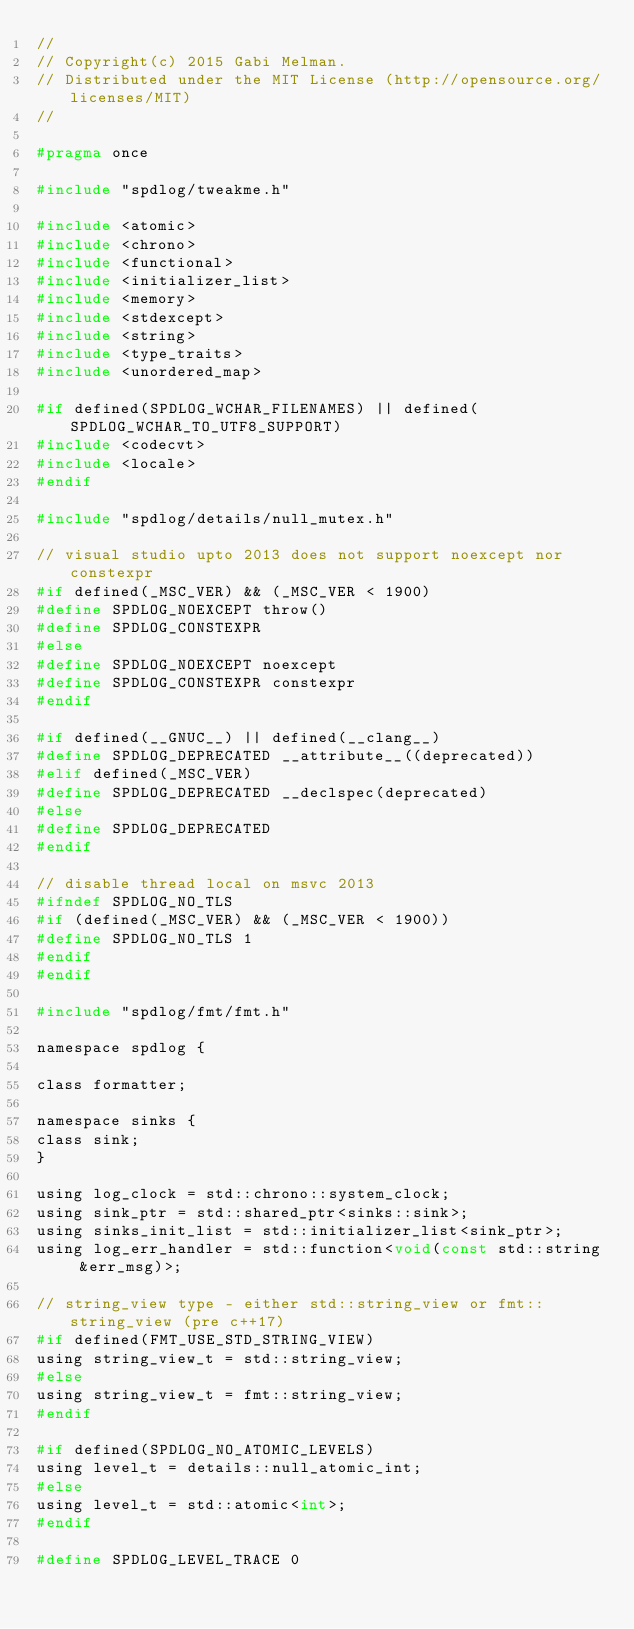Convert code to text. <code><loc_0><loc_0><loc_500><loc_500><_C_>//
// Copyright(c) 2015 Gabi Melman.
// Distributed under the MIT License (http://opensource.org/licenses/MIT)
//

#pragma once

#include "spdlog/tweakme.h"

#include <atomic>
#include <chrono>
#include <functional>
#include <initializer_list>
#include <memory>
#include <stdexcept>
#include <string>
#include <type_traits>
#include <unordered_map>

#if defined(SPDLOG_WCHAR_FILENAMES) || defined(SPDLOG_WCHAR_TO_UTF8_SUPPORT)
#include <codecvt>
#include <locale>
#endif

#include "spdlog/details/null_mutex.h"

// visual studio upto 2013 does not support noexcept nor constexpr
#if defined(_MSC_VER) && (_MSC_VER < 1900)
#define SPDLOG_NOEXCEPT throw()
#define SPDLOG_CONSTEXPR
#else
#define SPDLOG_NOEXCEPT noexcept
#define SPDLOG_CONSTEXPR constexpr
#endif

#if defined(__GNUC__) || defined(__clang__)
#define SPDLOG_DEPRECATED __attribute__((deprecated))
#elif defined(_MSC_VER)
#define SPDLOG_DEPRECATED __declspec(deprecated)
#else
#define SPDLOG_DEPRECATED
#endif

// disable thread local on msvc 2013
#ifndef SPDLOG_NO_TLS
#if (defined(_MSC_VER) && (_MSC_VER < 1900))
#define SPDLOG_NO_TLS 1
#endif
#endif

#include "spdlog/fmt/fmt.h"

namespace spdlog {

class formatter;

namespace sinks {
class sink;
}

using log_clock = std::chrono::system_clock;
using sink_ptr = std::shared_ptr<sinks::sink>;
using sinks_init_list = std::initializer_list<sink_ptr>;
using log_err_handler = std::function<void(const std::string &err_msg)>;

// string_view type - either std::string_view or fmt::string_view (pre c++17)
#if defined(FMT_USE_STD_STRING_VIEW)
using string_view_t = std::string_view;
#else
using string_view_t = fmt::string_view;
#endif

#if defined(SPDLOG_NO_ATOMIC_LEVELS)
using level_t = details::null_atomic_int;
#else
using level_t = std::atomic<int>;
#endif

#define SPDLOG_LEVEL_TRACE 0</code> 